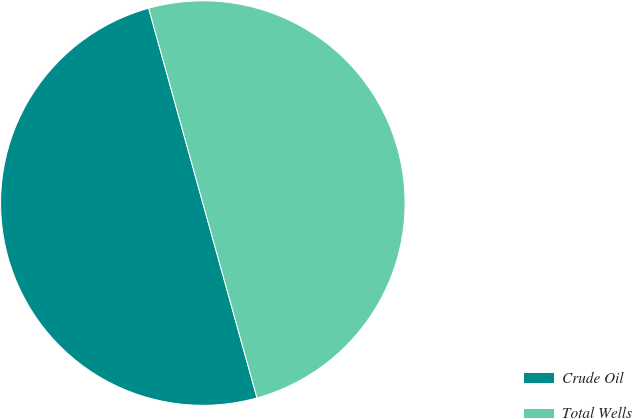Convert chart to OTSL. <chart><loc_0><loc_0><loc_500><loc_500><pie_chart><fcel>Crude Oil<fcel>Total Wells<nl><fcel>50.0%<fcel>50.0%<nl></chart> 